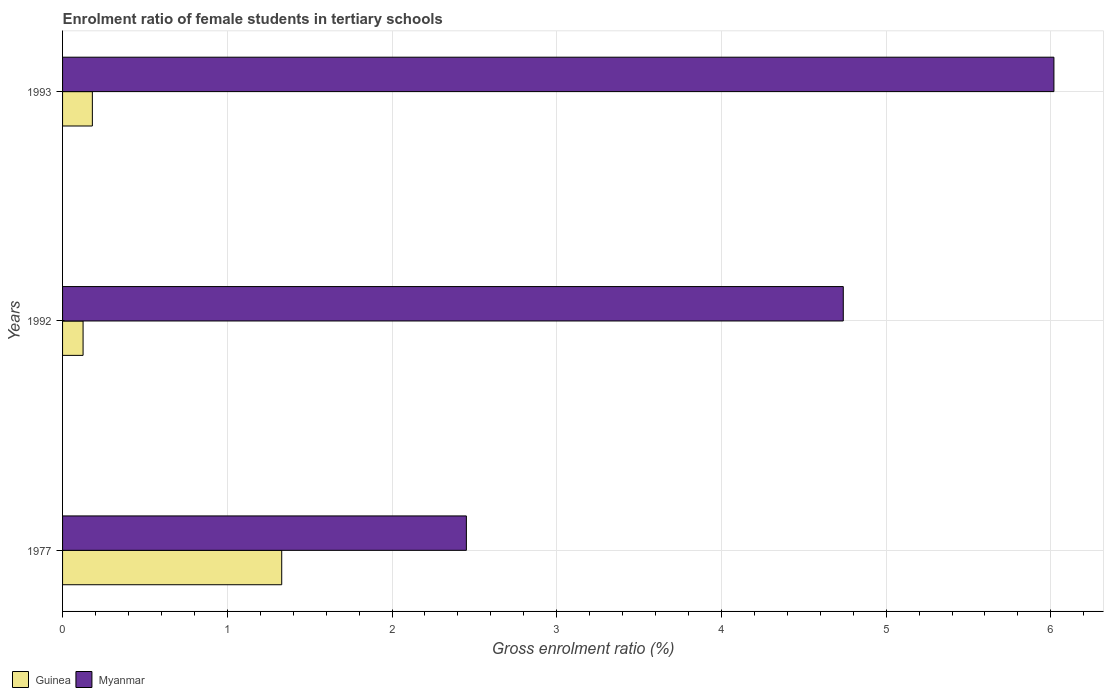How many groups of bars are there?
Your response must be concise. 3. What is the enrolment ratio of female students in tertiary schools in Myanmar in 1993?
Offer a terse response. 6.02. Across all years, what is the maximum enrolment ratio of female students in tertiary schools in Guinea?
Give a very brief answer. 1.33. Across all years, what is the minimum enrolment ratio of female students in tertiary schools in Guinea?
Give a very brief answer. 0.12. In which year was the enrolment ratio of female students in tertiary schools in Myanmar maximum?
Offer a very short reply. 1993. In which year was the enrolment ratio of female students in tertiary schools in Guinea minimum?
Your response must be concise. 1992. What is the total enrolment ratio of female students in tertiary schools in Guinea in the graph?
Keep it short and to the point. 1.64. What is the difference between the enrolment ratio of female students in tertiary schools in Guinea in 1977 and that in 1993?
Provide a succinct answer. 1.15. What is the difference between the enrolment ratio of female students in tertiary schools in Guinea in 1992 and the enrolment ratio of female students in tertiary schools in Myanmar in 1977?
Provide a short and direct response. -2.33. What is the average enrolment ratio of female students in tertiary schools in Guinea per year?
Offer a very short reply. 0.55. In the year 1992, what is the difference between the enrolment ratio of female students in tertiary schools in Myanmar and enrolment ratio of female students in tertiary schools in Guinea?
Provide a succinct answer. 4.62. What is the ratio of the enrolment ratio of female students in tertiary schools in Myanmar in 1977 to that in 1992?
Give a very brief answer. 0.52. Is the difference between the enrolment ratio of female students in tertiary schools in Myanmar in 1977 and 1993 greater than the difference between the enrolment ratio of female students in tertiary schools in Guinea in 1977 and 1993?
Your answer should be very brief. No. What is the difference between the highest and the second highest enrolment ratio of female students in tertiary schools in Guinea?
Keep it short and to the point. 1.15. What is the difference between the highest and the lowest enrolment ratio of female students in tertiary schools in Myanmar?
Give a very brief answer. 3.57. What does the 2nd bar from the top in 1992 represents?
Make the answer very short. Guinea. What does the 2nd bar from the bottom in 1993 represents?
Provide a short and direct response. Myanmar. How many years are there in the graph?
Ensure brevity in your answer.  3. What is the difference between two consecutive major ticks on the X-axis?
Your answer should be very brief. 1. Does the graph contain any zero values?
Keep it short and to the point. No. Does the graph contain grids?
Offer a terse response. Yes. What is the title of the graph?
Your answer should be very brief. Enrolment ratio of female students in tertiary schools. What is the label or title of the X-axis?
Provide a short and direct response. Gross enrolment ratio (%). What is the label or title of the Y-axis?
Make the answer very short. Years. What is the Gross enrolment ratio (%) in Guinea in 1977?
Your answer should be very brief. 1.33. What is the Gross enrolment ratio (%) of Myanmar in 1977?
Make the answer very short. 2.45. What is the Gross enrolment ratio (%) in Guinea in 1992?
Your answer should be very brief. 0.12. What is the Gross enrolment ratio (%) in Myanmar in 1992?
Make the answer very short. 4.74. What is the Gross enrolment ratio (%) in Guinea in 1993?
Give a very brief answer. 0.18. What is the Gross enrolment ratio (%) of Myanmar in 1993?
Your response must be concise. 6.02. Across all years, what is the maximum Gross enrolment ratio (%) in Guinea?
Keep it short and to the point. 1.33. Across all years, what is the maximum Gross enrolment ratio (%) in Myanmar?
Offer a very short reply. 6.02. Across all years, what is the minimum Gross enrolment ratio (%) in Guinea?
Keep it short and to the point. 0.12. Across all years, what is the minimum Gross enrolment ratio (%) of Myanmar?
Provide a succinct answer. 2.45. What is the total Gross enrolment ratio (%) of Guinea in the graph?
Offer a terse response. 1.64. What is the total Gross enrolment ratio (%) of Myanmar in the graph?
Your answer should be compact. 13.21. What is the difference between the Gross enrolment ratio (%) of Guinea in 1977 and that in 1992?
Your response must be concise. 1.21. What is the difference between the Gross enrolment ratio (%) in Myanmar in 1977 and that in 1992?
Offer a very short reply. -2.29. What is the difference between the Gross enrolment ratio (%) in Guinea in 1977 and that in 1993?
Provide a succinct answer. 1.15. What is the difference between the Gross enrolment ratio (%) in Myanmar in 1977 and that in 1993?
Keep it short and to the point. -3.57. What is the difference between the Gross enrolment ratio (%) in Guinea in 1992 and that in 1993?
Your answer should be compact. -0.06. What is the difference between the Gross enrolment ratio (%) in Myanmar in 1992 and that in 1993?
Provide a short and direct response. -1.28. What is the difference between the Gross enrolment ratio (%) in Guinea in 1977 and the Gross enrolment ratio (%) in Myanmar in 1992?
Your answer should be very brief. -3.41. What is the difference between the Gross enrolment ratio (%) in Guinea in 1977 and the Gross enrolment ratio (%) in Myanmar in 1993?
Make the answer very short. -4.69. What is the difference between the Gross enrolment ratio (%) in Guinea in 1992 and the Gross enrolment ratio (%) in Myanmar in 1993?
Make the answer very short. -5.89. What is the average Gross enrolment ratio (%) of Guinea per year?
Keep it short and to the point. 0.55. What is the average Gross enrolment ratio (%) in Myanmar per year?
Provide a short and direct response. 4.4. In the year 1977, what is the difference between the Gross enrolment ratio (%) in Guinea and Gross enrolment ratio (%) in Myanmar?
Provide a succinct answer. -1.12. In the year 1992, what is the difference between the Gross enrolment ratio (%) of Guinea and Gross enrolment ratio (%) of Myanmar?
Your answer should be very brief. -4.62. In the year 1993, what is the difference between the Gross enrolment ratio (%) in Guinea and Gross enrolment ratio (%) in Myanmar?
Give a very brief answer. -5.84. What is the ratio of the Gross enrolment ratio (%) of Guinea in 1977 to that in 1992?
Provide a short and direct response. 10.69. What is the ratio of the Gross enrolment ratio (%) in Myanmar in 1977 to that in 1992?
Your response must be concise. 0.52. What is the ratio of the Gross enrolment ratio (%) in Guinea in 1977 to that in 1993?
Offer a terse response. 7.35. What is the ratio of the Gross enrolment ratio (%) of Myanmar in 1977 to that in 1993?
Offer a very short reply. 0.41. What is the ratio of the Gross enrolment ratio (%) of Guinea in 1992 to that in 1993?
Provide a succinct answer. 0.69. What is the ratio of the Gross enrolment ratio (%) in Myanmar in 1992 to that in 1993?
Offer a very short reply. 0.79. What is the difference between the highest and the second highest Gross enrolment ratio (%) of Guinea?
Ensure brevity in your answer.  1.15. What is the difference between the highest and the second highest Gross enrolment ratio (%) in Myanmar?
Give a very brief answer. 1.28. What is the difference between the highest and the lowest Gross enrolment ratio (%) in Guinea?
Provide a succinct answer. 1.21. What is the difference between the highest and the lowest Gross enrolment ratio (%) of Myanmar?
Provide a succinct answer. 3.57. 